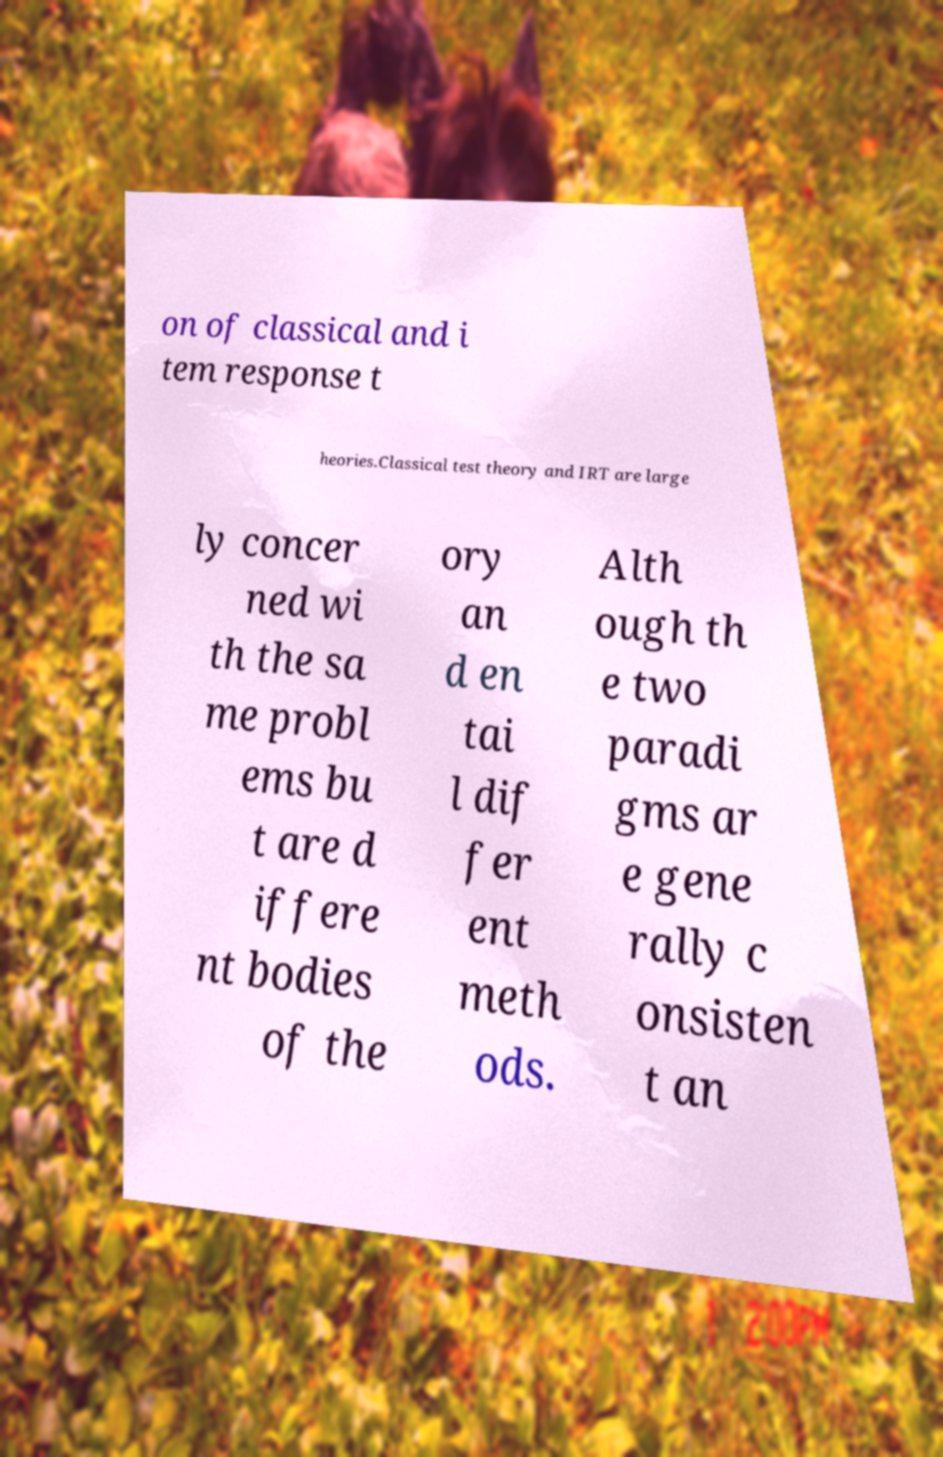Can you accurately transcribe the text from the provided image for me? on of classical and i tem response t heories.Classical test theory and IRT are large ly concer ned wi th the sa me probl ems bu t are d iffere nt bodies of the ory an d en tai l dif fer ent meth ods. Alth ough th e two paradi gms ar e gene rally c onsisten t an 